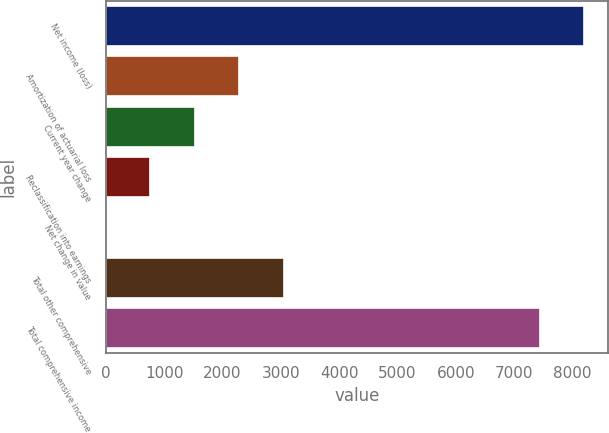<chart> <loc_0><loc_0><loc_500><loc_500><bar_chart><fcel>Net income (loss)<fcel>Amortization of actuarial loss<fcel>Current year change<fcel>Reclassification into earnings<fcel>Net change in value<fcel>Total other comprehensive<fcel>Total comprehensive income<nl><fcel>8197.5<fcel>2286.5<fcel>1526<fcel>765.5<fcel>5<fcel>3047<fcel>7437<nl></chart> 